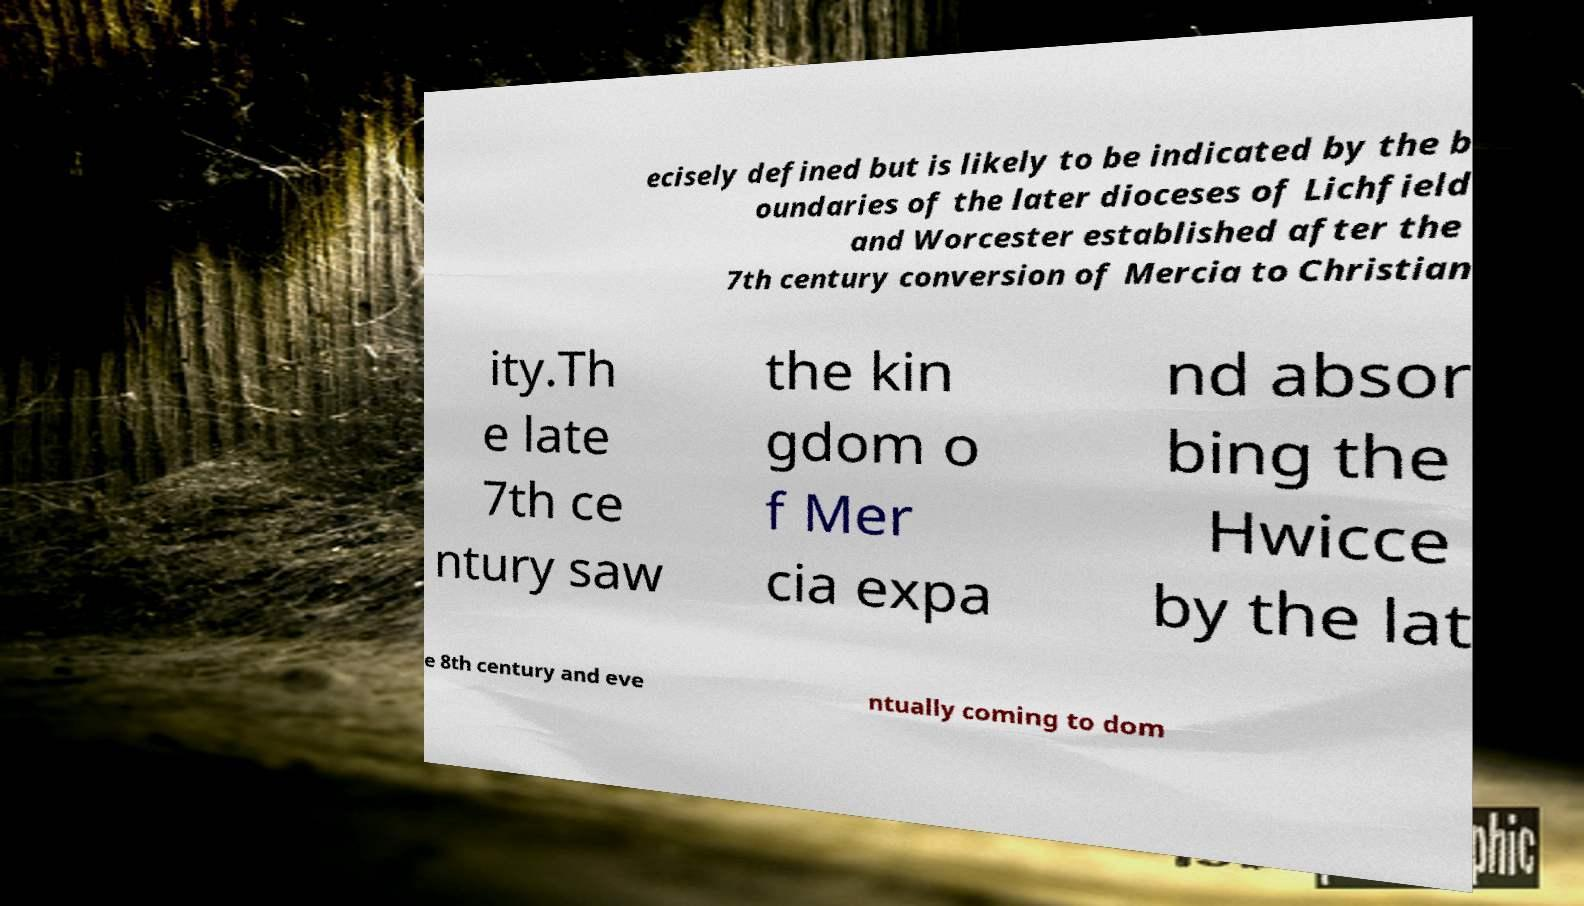Can you read and provide the text displayed in the image?This photo seems to have some interesting text. Can you extract and type it out for me? ecisely defined but is likely to be indicated by the b oundaries of the later dioceses of Lichfield and Worcester established after the 7th century conversion of Mercia to Christian ity.Th e late 7th ce ntury saw the kin gdom o f Mer cia expa nd absor bing the Hwicce by the lat e 8th century and eve ntually coming to dom 